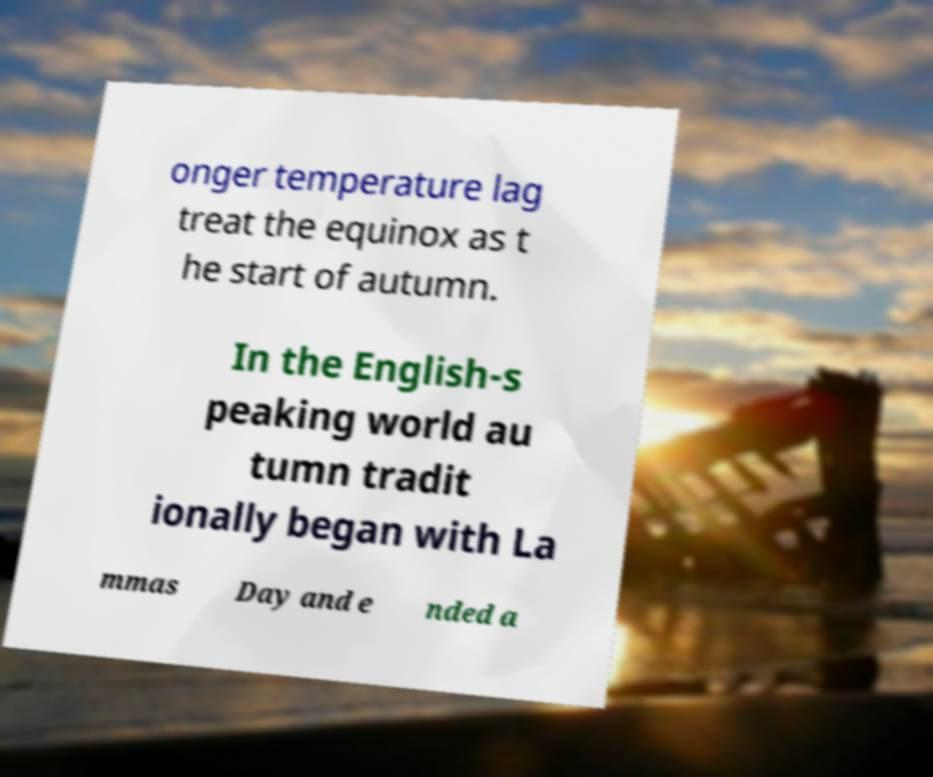I need the written content from this picture converted into text. Can you do that? onger temperature lag treat the equinox as t he start of autumn. In the English-s peaking world au tumn tradit ionally began with La mmas Day and e nded a 